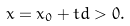Convert formula to latex. <formula><loc_0><loc_0><loc_500><loc_500>x = x _ { 0 } + t d > 0 .</formula> 